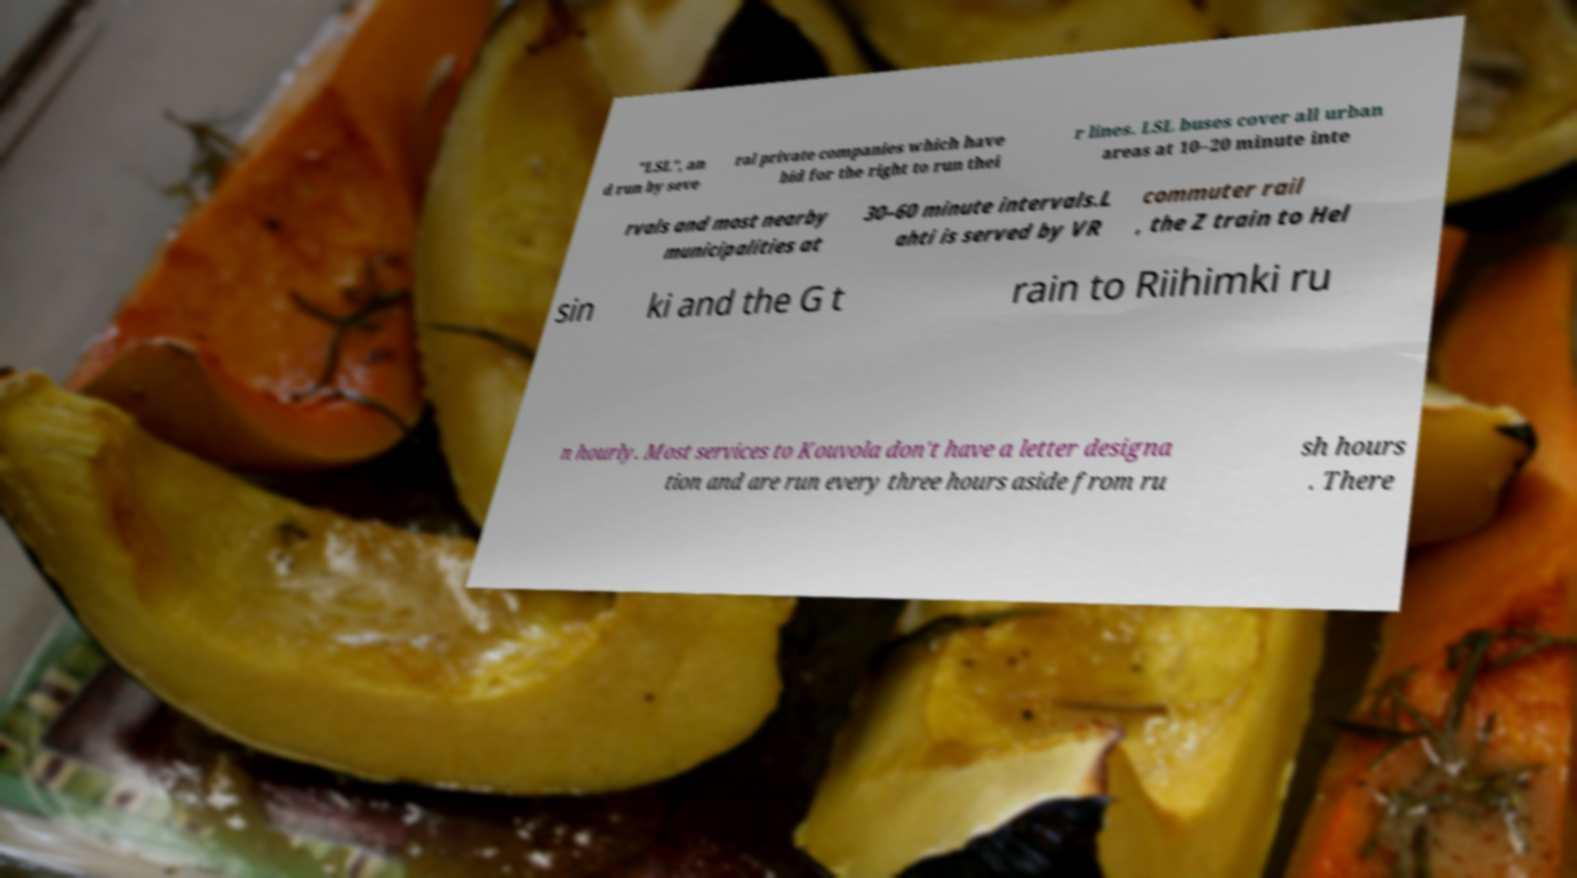Could you extract and type out the text from this image? "LSL", an d run by seve ral private companies which have bid for the right to run thei r lines. LSL buses cover all urban areas at 10–20 minute inte rvals and most nearby municipalities at 30–60 minute intervals.L ahti is served by VR commuter rail , the Z train to Hel sin ki and the G t rain to Riihimki ru n hourly. Most services to Kouvola don't have a letter designa tion and are run every three hours aside from ru sh hours . There 